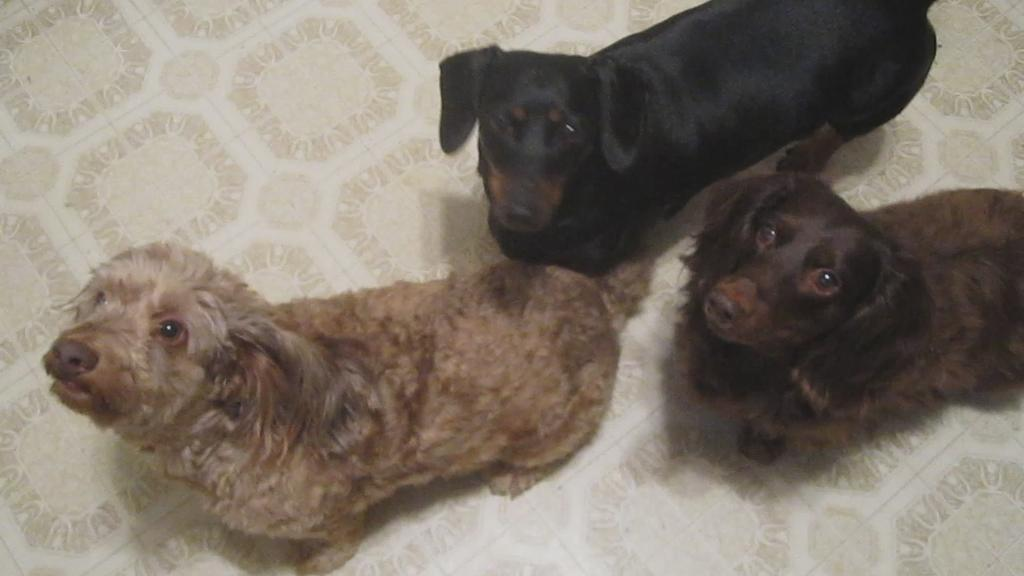How many dogs are present in the image? There are three dogs in the image. Can you describe the color of each dog? One dog is brown, one dog is black, and one dog is cream-colored. What type of icicle can be seen hanging from the dog's mouth in the image? There is no icicle present in the image, and none of the dogs have anything hanging from their mouths. 